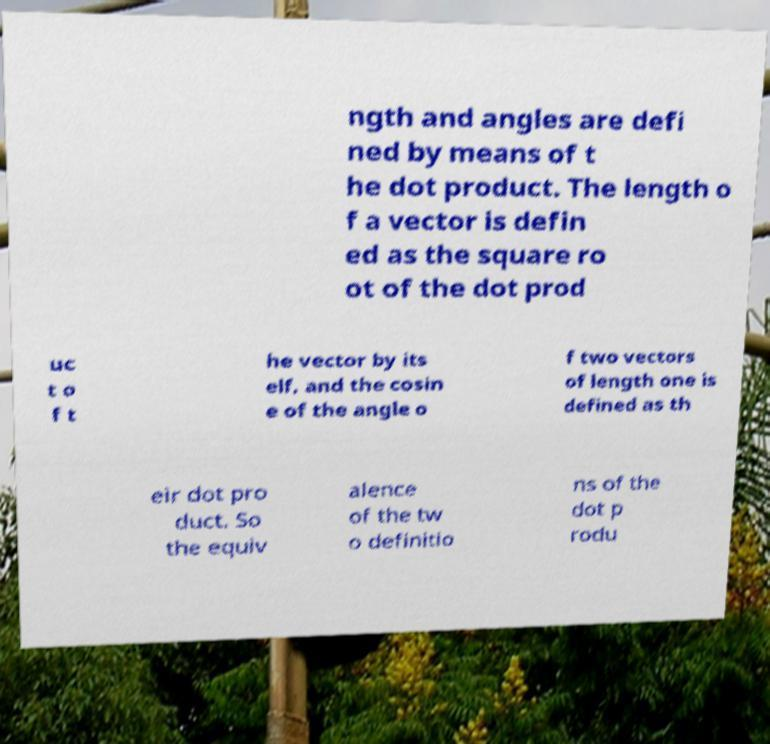There's text embedded in this image that I need extracted. Can you transcribe it verbatim? ngth and angles are defi ned by means of t he dot product. The length o f a vector is defin ed as the square ro ot of the dot prod uc t o f t he vector by its elf, and the cosin e of the angle o f two vectors of length one is defined as th eir dot pro duct. So the equiv alence of the tw o definitio ns of the dot p rodu 